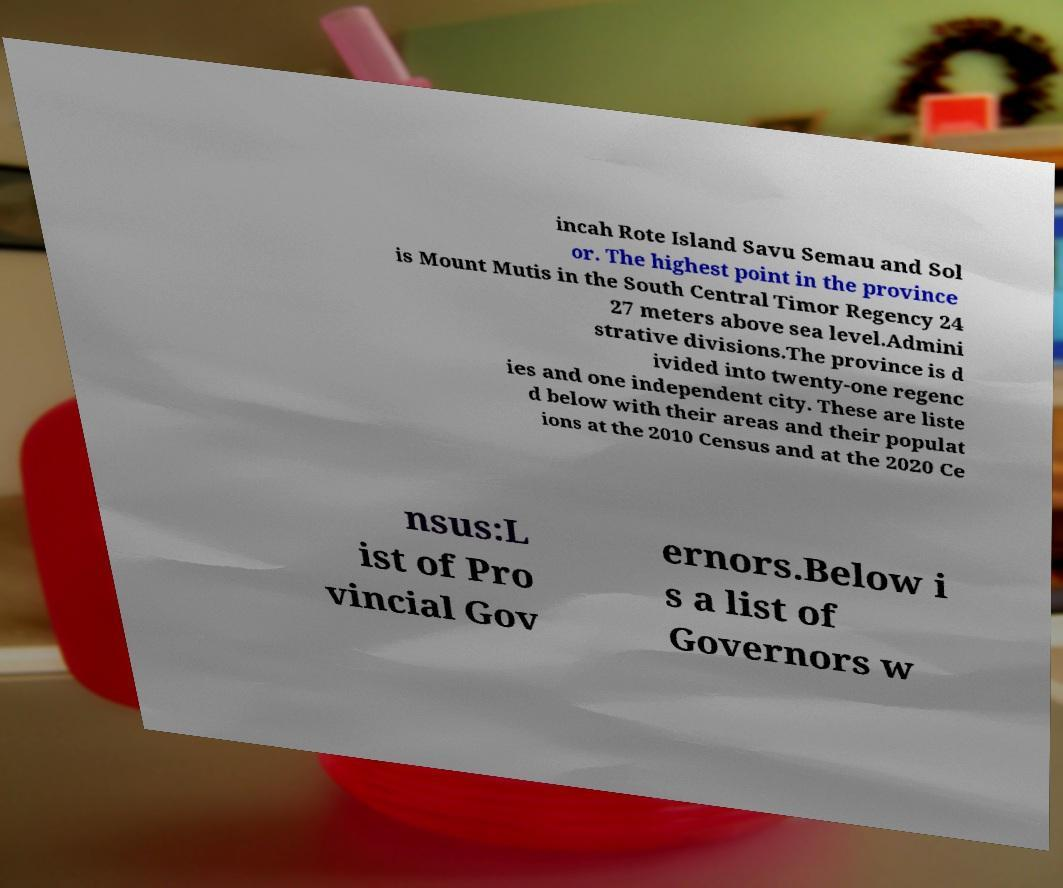Please identify and transcribe the text found in this image. incah Rote Island Savu Semau and Sol or. The highest point in the province is Mount Mutis in the South Central Timor Regency 24 27 meters above sea level.Admini strative divisions.The province is d ivided into twenty-one regenc ies and one independent city. These are liste d below with their areas and their populat ions at the 2010 Census and at the 2020 Ce nsus:L ist of Pro vincial Gov ernors.Below i s a list of Governors w 